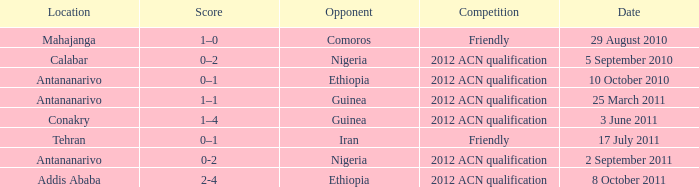What is the score at the Addis Ababa location? 2-4. 